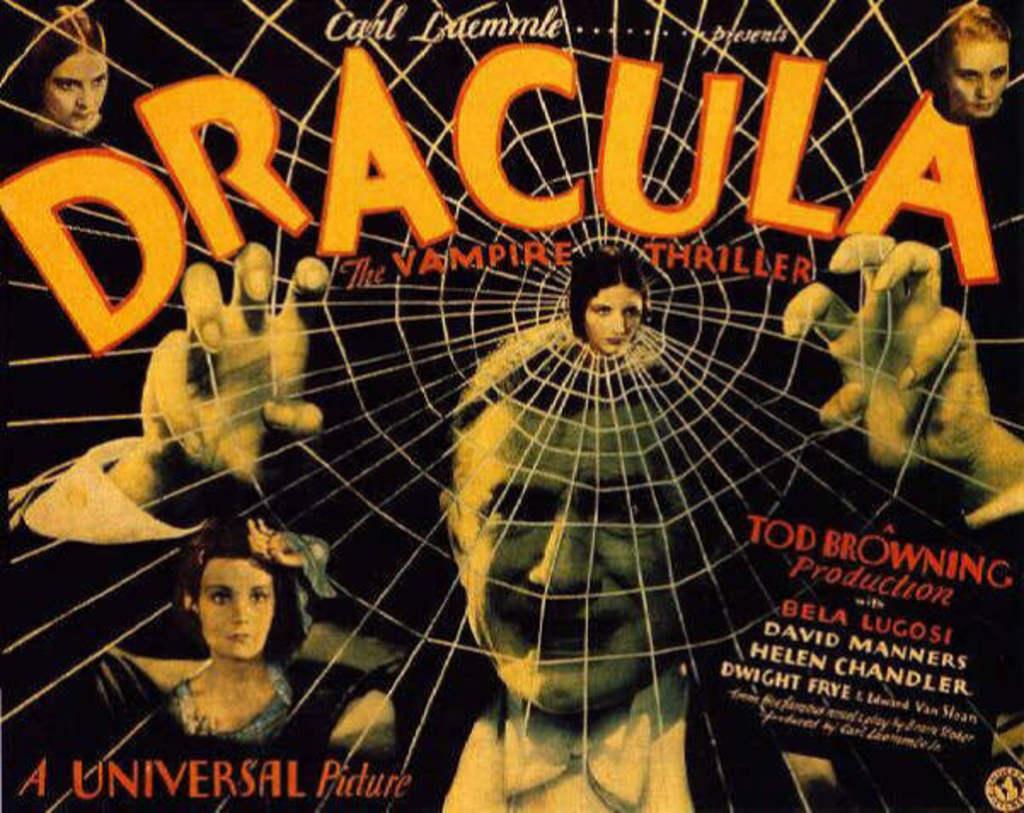What do the colorful letters say?
Provide a succinct answer. Dracula. What is an actor in it?
Offer a very short reply. Bela lugosi. 